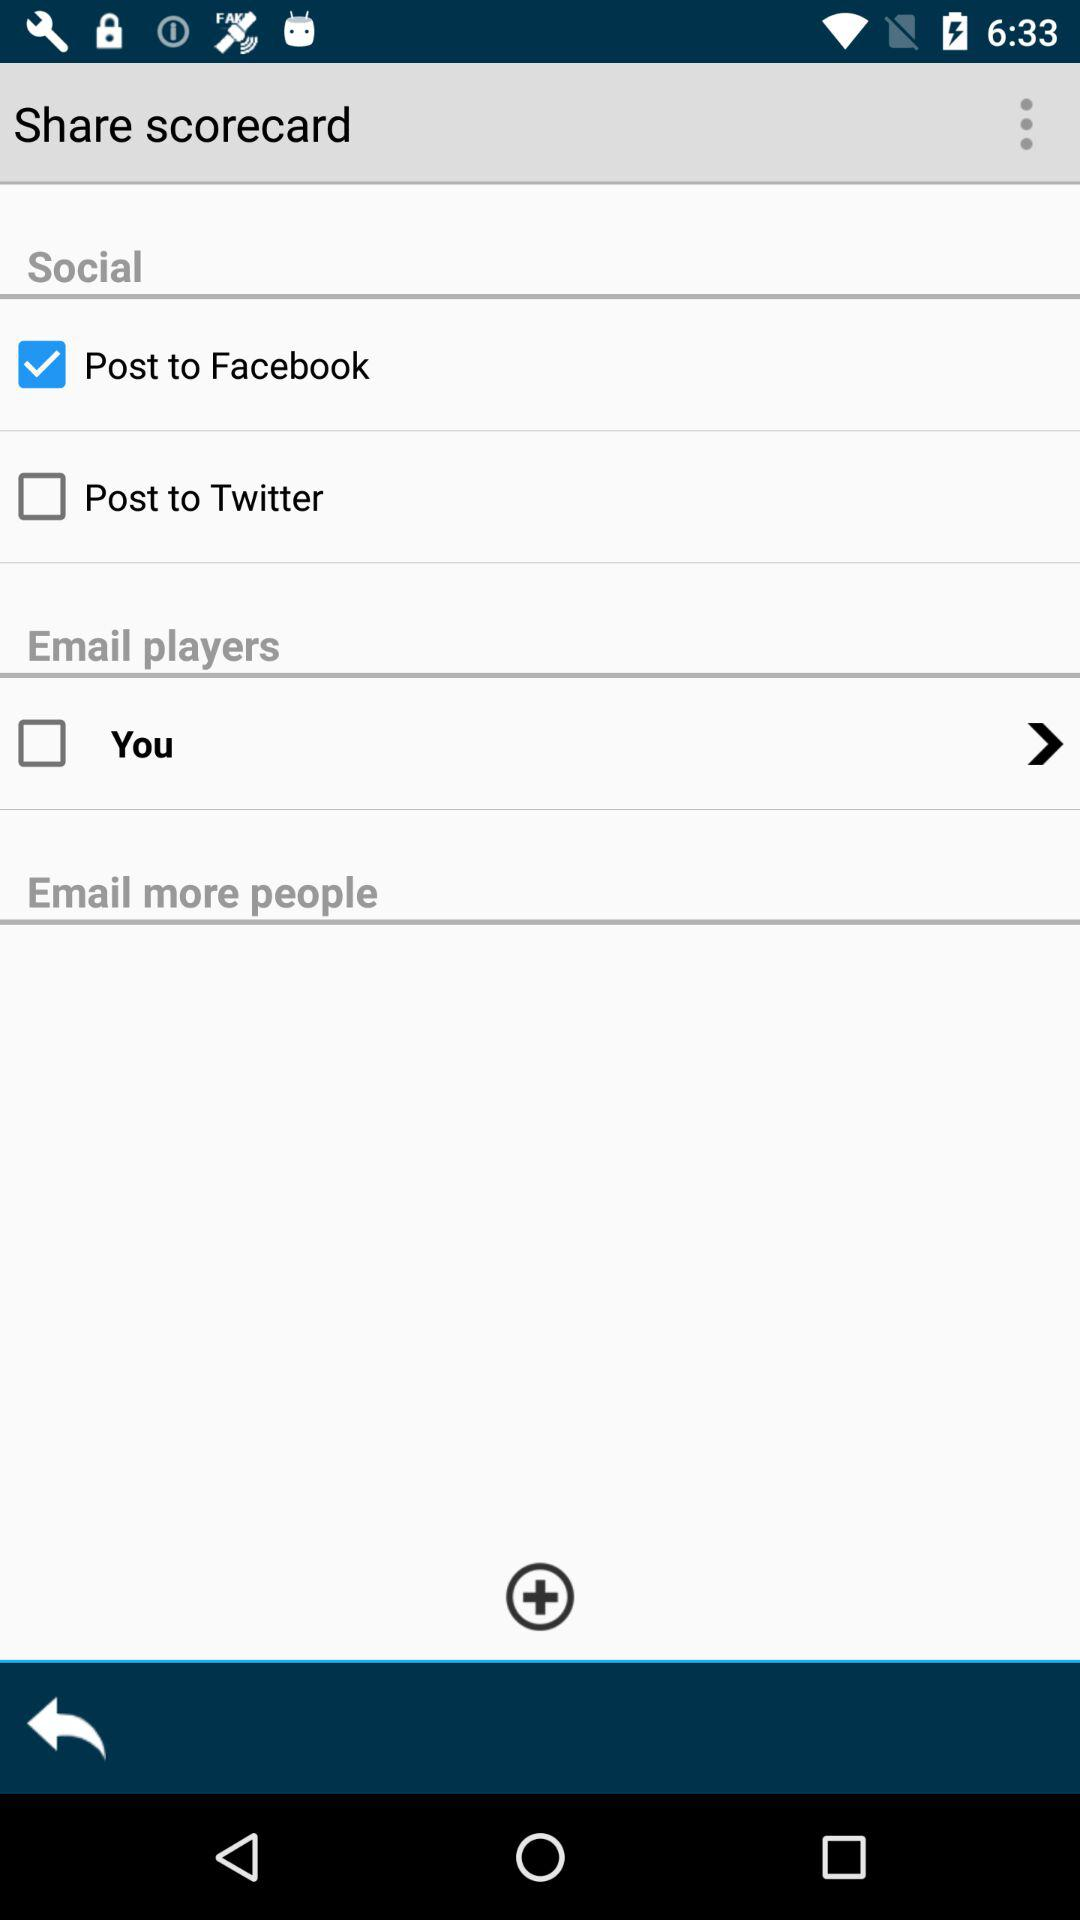What's the selected option in "Social"? The selected option is "Post to Facebook". 